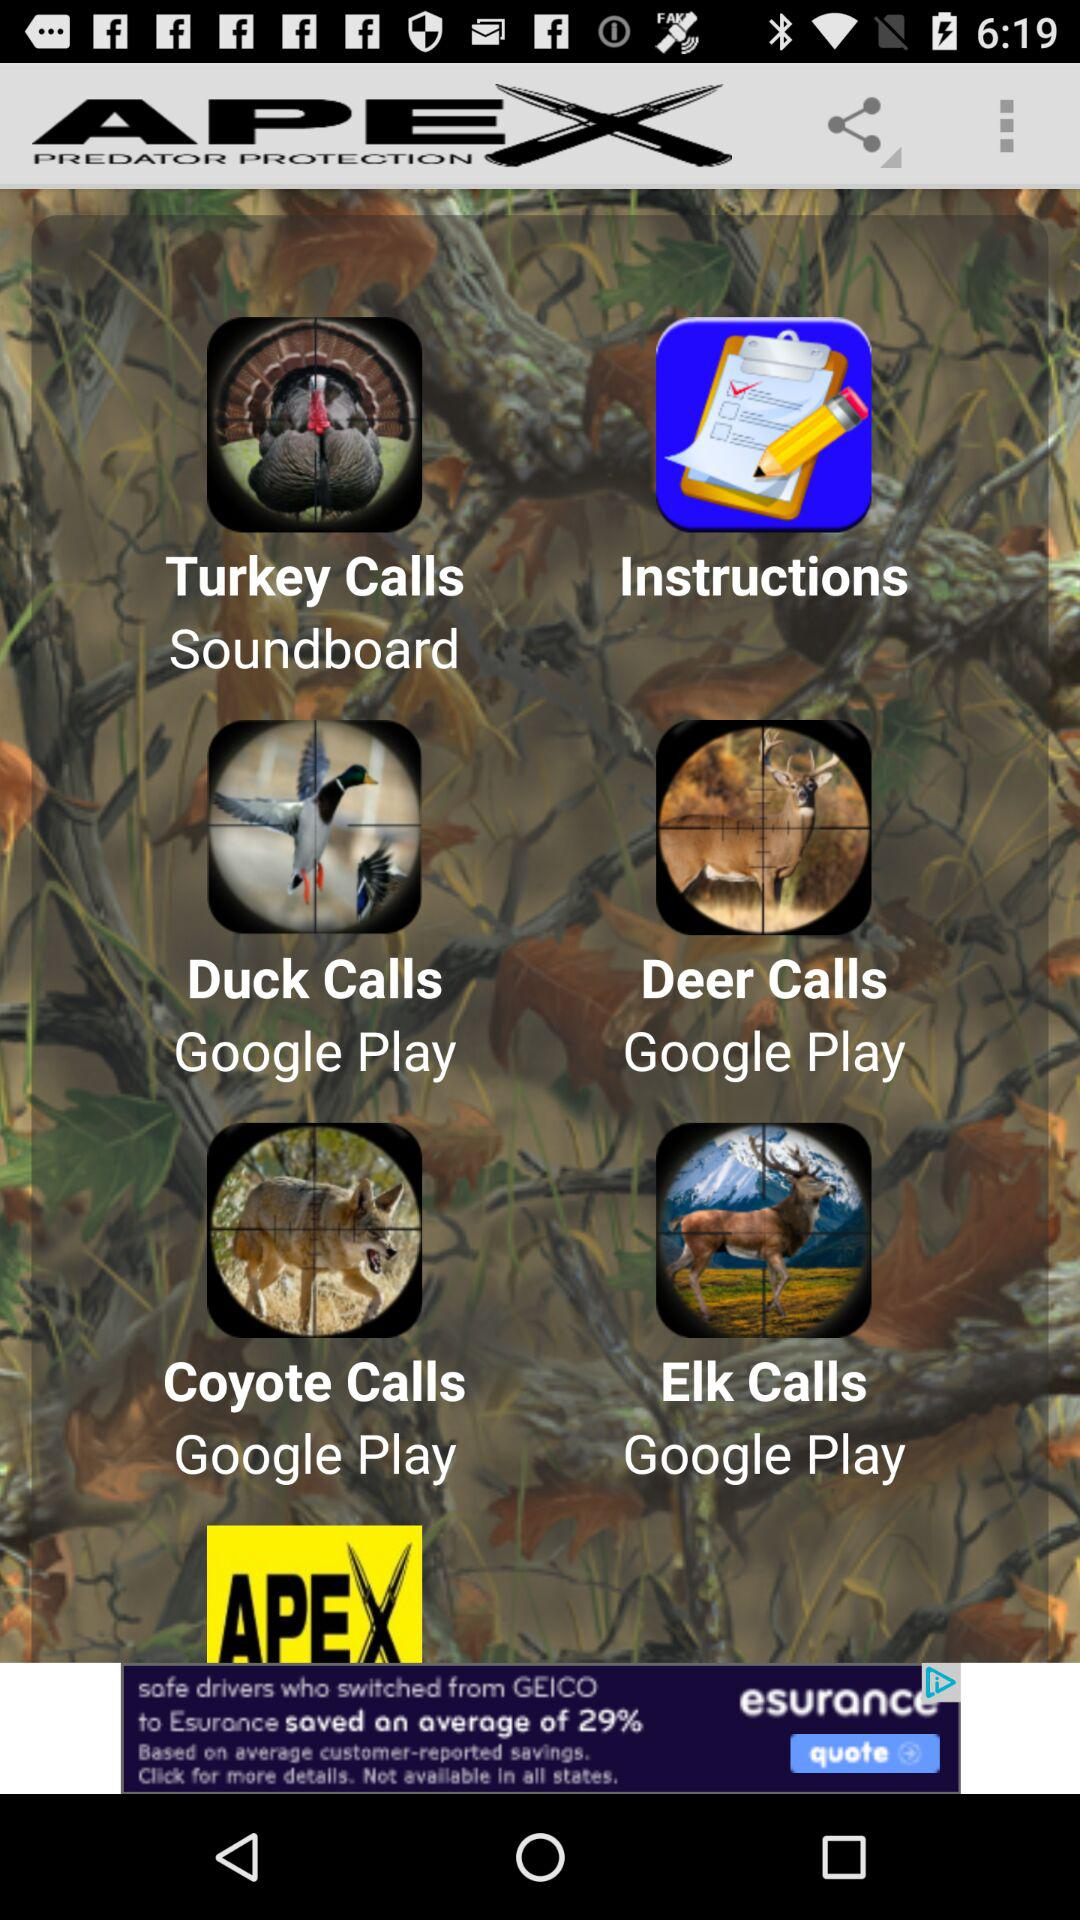How much does "Turkey Calls" cost?
When the provided information is insufficient, respond with <no answer>. <no answer> 